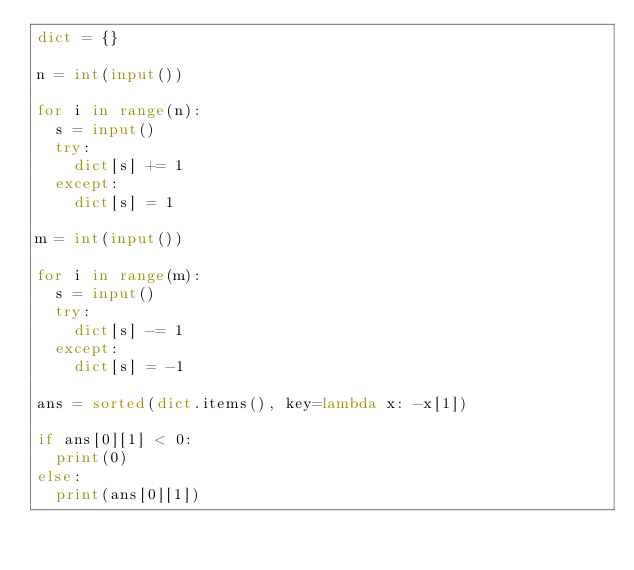Convert code to text. <code><loc_0><loc_0><loc_500><loc_500><_Python_>dict = {}

n = int(input())

for i in range(n):
	s = input()
	try:
		dict[s] += 1
	except:
		dict[s] = 1

m = int(input())

for i in range(m):
	s = input()
	try:
		dict[s] -= 1
	except:
		dict[s] = -1

ans = sorted(dict.items(), key=lambda x: -x[1])

if ans[0][1] < 0:
	print(0)
else:
	print(ans[0][1])</code> 